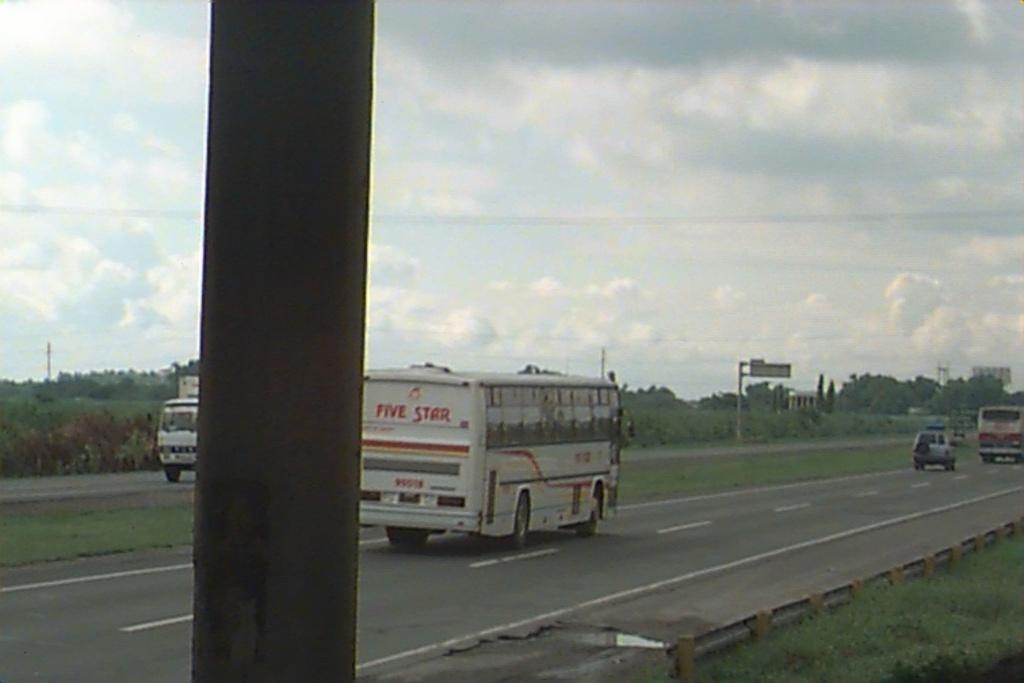Describe this image in one or two sentences. In this image we can see roads. There are vehicles. Also we can see a pole. In the background there are trees. Near to the road there is water. And there is a small railing near to the road. In the background there is sky with clouds. And there is a pole with a board. 